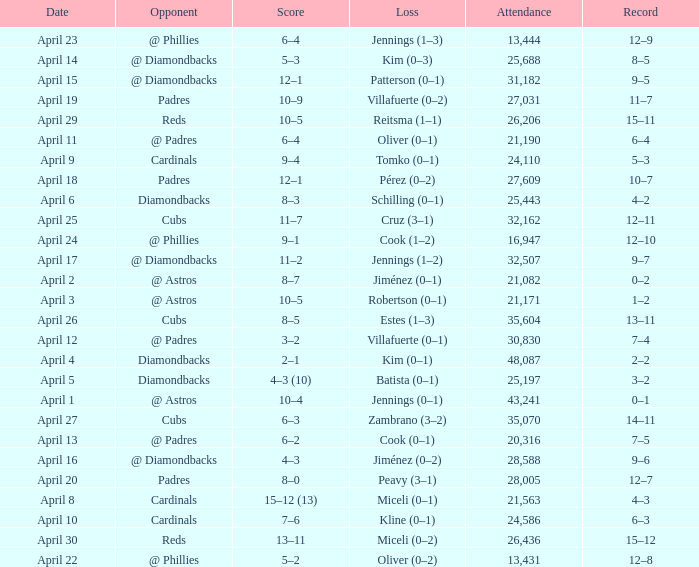Can you give me this table as a dict? {'header': ['Date', 'Opponent', 'Score', 'Loss', 'Attendance', 'Record'], 'rows': [['April 23', '@ Phillies', '6–4', 'Jennings (1–3)', '13,444', '12–9'], ['April 14', '@ Diamondbacks', '5–3', 'Kim (0–3)', '25,688', '8–5'], ['April 15', '@ Diamondbacks', '12–1', 'Patterson (0–1)', '31,182', '9–5'], ['April 19', 'Padres', '10–9', 'Villafuerte (0–2)', '27,031', '11–7'], ['April 29', 'Reds', '10–5', 'Reitsma (1–1)', '26,206', '15–11'], ['April 11', '@ Padres', '6–4', 'Oliver (0–1)', '21,190', '6–4'], ['April 9', 'Cardinals', '9–4', 'Tomko (0–1)', '24,110', '5–3'], ['April 18', 'Padres', '12–1', 'Pérez (0–2)', '27,609', '10–7'], ['April 6', 'Diamondbacks', '8–3', 'Schilling (0–1)', '25,443', '4–2'], ['April 25', 'Cubs', '11–7', 'Cruz (3–1)', '32,162', '12–11'], ['April 24', '@ Phillies', '9–1', 'Cook (1–2)', '16,947', '12–10'], ['April 17', '@ Diamondbacks', '11–2', 'Jennings (1–2)', '32,507', '9–7'], ['April 2', '@ Astros', '8–7', 'Jiménez (0–1)', '21,082', '0–2'], ['April 3', '@ Astros', '10–5', 'Robertson (0–1)', '21,171', '1–2'], ['April 26', 'Cubs', '8–5', 'Estes (1–3)', '35,604', '13–11'], ['April 12', '@ Padres', '3–2', 'Villafuerte (0–1)', '30,830', '7–4'], ['April 4', 'Diamondbacks', '2–1', 'Kim (0–1)', '48,087', '2–2'], ['April 5', 'Diamondbacks', '4–3 (10)', 'Batista (0–1)', '25,197', '3–2'], ['April 1', '@ Astros', '10–4', 'Jennings (0–1)', '43,241', '0–1'], ['April 27', 'Cubs', '6–3', 'Zambrano (3–2)', '35,070', '14–11'], ['April 13', '@ Padres', '6–2', 'Cook (0–1)', '20,316', '7–5'], ['April 16', '@ Diamondbacks', '4–3', 'Jiménez (0–2)', '28,588', '9–6'], ['April 20', 'Padres', '8–0', 'Peavy (3–1)', '28,005', '12–7'], ['April 8', 'Cardinals', '15–12 (13)', 'Miceli (0–1)', '21,563', '4–3'], ['April 10', 'Cardinals', '7–6', 'Kline (0–1)', '24,586', '6–3'], ['April 30', 'Reds', '13–11', 'Miceli (0–2)', '26,436', '15–12'], ['April 22', '@ Phillies', '5–2', 'Oliver (0–2)', '13,431', '12–8']]} Who is the opponent on april 16? @ Diamondbacks. 